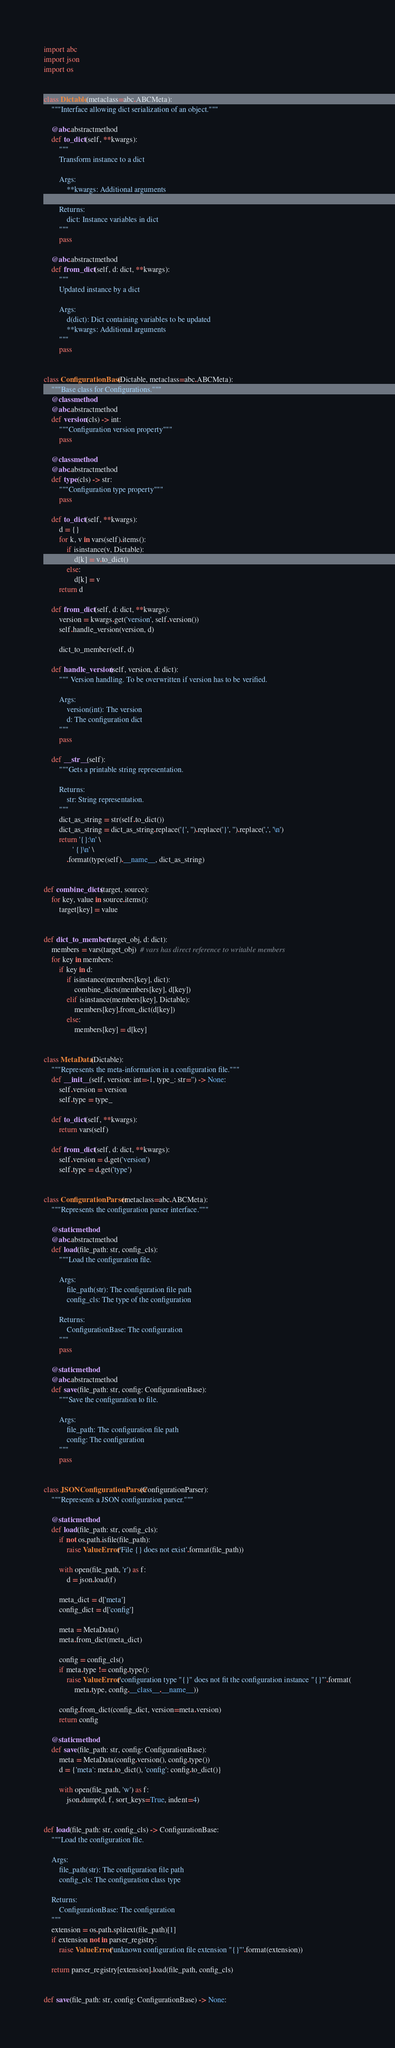<code> <loc_0><loc_0><loc_500><loc_500><_Python_>import abc
import json
import os


class Dictable(metaclass=abc.ABCMeta):
    """Interface allowing dict serialization of an object."""

    @abc.abstractmethod
    def to_dict(self, **kwargs):
        """
        Transform instance to a dict

        Args:
            **kwargs: Additional arguments

        Returns:
            dict: Instance variables in dict
        """
        pass

    @abc.abstractmethod
    def from_dict(self, d: dict, **kwargs):
        """
        Updated instance by a dict

        Args:
            d(dict): Dict containing variables to be updated
            **kwargs: Additional arguments
        """
        pass


class ConfigurationBase(Dictable, metaclass=abc.ABCMeta):
    """Base class for Configurations."""
    @classmethod
    @abc.abstractmethod
    def version(cls) -> int:
        """Configuration version property"""
        pass

    @classmethod
    @abc.abstractmethod
    def type(cls) -> str:
        """Configuration type property"""
        pass

    def to_dict(self, **kwargs):
        d = {}
        for k, v in vars(self).items():
            if isinstance(v, Dictable):
                d[k] = v.to_dict()
            else:
                d[k] = v
        return d

    def from_dict(self, d: dict, **kwargs):
        version = kwargs.get('version', self.version())
        self.handle_version(version, d)

        dict_to_member(self, d)

    def handle_version(self, version, d: dict):
        """ Version handling. To be overwritten if version has to be verified.

        Args:
            version(int): The version
            d: The configuration dict
        """
        pass

    def __str__(self):
        """Gets a printable string representation.

        Returns:
            str: String representation.
        """
        dict_as_string = str(self.to_dict())
        dict_as_string = dict_as_string.replace('{', '').replace('}', '').replace(',', '\n')
        return '{}:\n' \
               ' {}\n' \
            .format(type(self).__name__, dict_as_string)


def combine_dicts(target, source):
    for key, value in source.items():
        target[key] = value


def dict_to_member(target_obj, d: dict):
    members = vars(target_obj)  # vars has direct reference to writable members
    for key in members:
        if key in d:
            if isinstance(members[key], dict):
                combine_dicts(members[key], d[key])
            elif isinstance(members[key], Dictable):
                members[key].from_dict(d[key])
            else:
                members[key] = d[key]


class MetaData(Dictable):
    """Represents the meta-information in a configuration file."""
    def __init__(self, version: int=-1, type_: str='') -> None:
        self.version = version
        self.type = type_

    def to_dict(self, **kwargs):
        return vars(self)

    def from_dict(self, d: dict, **kwargs):
        self.version = d.get('version')
        self.type = d.get('type')


class ConfigurationParser(metaclass=abc.ABCMeta):
    """Represents the configuration parser interface."""

    @staticmethod
    @abc.abstractmethod
    def load(file_path: str, config_cls):
        """Load the configuration file.

        Args:
            file_path(str): The configuration file path
            config_cls: The type of the configuration

        Returns:
            ConfigurationBase: The configuration
        """
        pass

    @staticmethod
    @abc.abstractmethod
    def save(file_path: str, config: ConfigurationBase):
        """Save the configuration to file.

        Args:
            file_path: The configuration file path
            config: The configuration
        """
        pass


class JSONConfigurationParser(ConfigurationParser):
    """Represents a JSON configuration parser."""

    @staticmethod
    def load(file_path: str, config_cls):
        if not os.path.isfile(file_path):
            raise ValueError('File {} does not exist'.format(file_path))

        with open(file_path, 'r') as f:
            d = json.load(f)

        meta_dict = d['meta']
        config_dict = d['config']

        meta = MetaData()
        meta.from_dict(meta_dict)

        config = config_cls()
        if meta.type != config.type():
            raise ValueError('configuration type "{}" does not fit the configuration instance "{}"'.format(
                meta.type, config.__class__.__name__))

        config.from_dict(config_dict, version=meta.version)
        return config

    @staticmethod
    def save(file_path: str, config: ConfigurationBase):
        meta = MetaData(config.version(), config.type())
        d = {'meta': meta.to_dict(), 'config': config.to_dict()}

        with open(file_path, 'w') as f:
            json.dump(d, f, sort_keys=True, indent=4)


def load(file_path: str, config_cls) -> ConfigurationBase:
    """Load the configuration file.

    Args:
        file_path(str): The configuration file path
        config_cls: The configuration class type

    Returns:
        ConfigurationBase: The configuration
    """
    extension = os.path.splitext(file_path)[1]
    if extension not in parser_registry:
        raise ValueError('unknown configuration file extension "{}"'.format(extension))

    return parser_registry[extension].load(file_path, config_cls)


def save(file_path: str, config: ConfigurationBase) -> None:</code> 